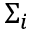Convert formula to latex. <formula><loc_0><loc_0><loc_500><loc_500>\Sigma _ { i }</formula> 